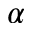<formula> <loc_0><loc_0><loc_500><loc_500>\alpha</formula> 